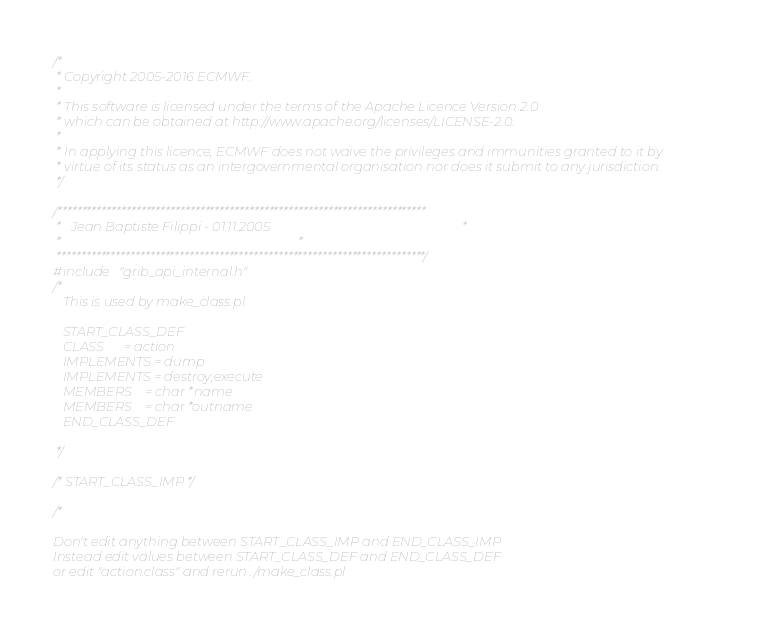<code> <loc_0><loc_0><loc_500><loc_500><_C_>/*
 * Copyright 2005-2016 ECMWF.
 *
 * This software is licensed under the terms of the Apache Licence Version 2.0
 * which can be obtained at http://www.apache.org/licenses/LICENSE-2.0.
 *
 * In applying this licence, ECMWF does not waive the privileges and immunities granted to it by
 * virtue of its status as an intergovernmental organisation nor does it submit to any jurisdiction.
 */

/***************************************************************************
 *   Jean Baptiste Filippi - 01.11.2005                                                           *
 *                                                                         *
 ***************************************************************************/
#include "grib_api_internal.h"
/*
   This is used by make_class.pl

   START_CLASS_DEF
   CLASS      = action
   IMPLEMENTS = dump
   IMPLEMENTS = destroy;execute
   MEMBERS    = char *name
   MEMBERS    = char *outname
   END_CLASS_DEF

 */

/* START_CLASS_IMP */

/*

Don't edit anything between START_CLASS_IMP and END_CLASS_IMP
Instead edit values between START_CLASS_DEF and END_CLASS_DEF
or edit "action.class" and rerun ./make_class.pl
</code> 